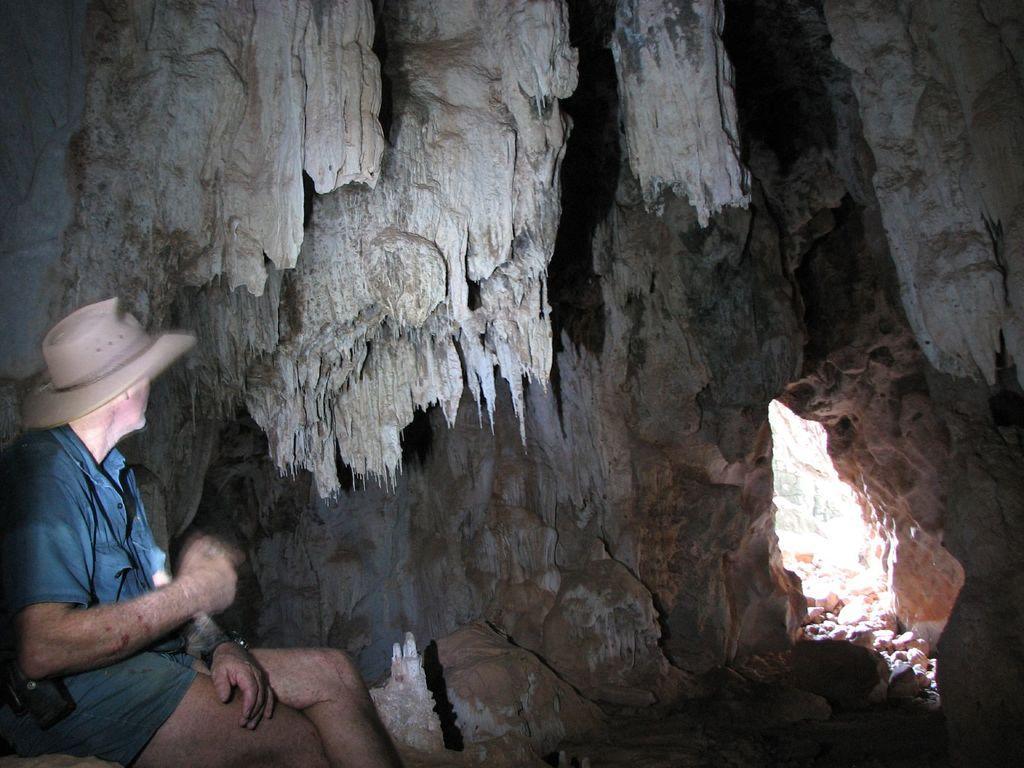In one or two sentences, can you explain what this image depicts? In this image we can see a cake and a man. The man is wearing a shirt, shorts, watch and a hat. 